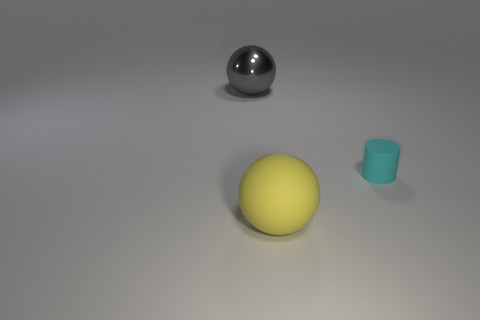There is a thing that is both to the left of the rubber cylinder and behind the big yellow rubber object; what material is it made of?
Make the answer very short. Metal. The small thing that is made of the same material as the large yellow sphere is what shape?
Ensure brevity in your answer.  Cylinder. There is a matte ball in front of the cyan matte cylinder; how many cyan cylinders are right of it?
Offer a very short reply. 1. How many objects are both behind the tiny cyan rubber object and to the right of the large yellow matte sphere?
Your answer should be very brief. 0. How many other things are there of the same material as the cyan object?
Your response must be concise. 1. There is a ball right of the thing that is to the left of the big yellow matte thing; what color is it?
Provide a short and direct response. Yellow. Does the big thing that is behind the cyan rubber thing have the same color as the tiny matte cylinder?
Ensure brevity in your answer.  No. Do the yellow matte sphere and the cyan rubber thing have the same size?
Your response must be concise. No. There is a ball that is behind the cylinder; is it the same size as the large yellow rubber ball?
Offer a very short reply. Yes. There is a yellow ball that is the same size as the gray metal sphere; what is its material?
Your answer should be compact. Rubber. 